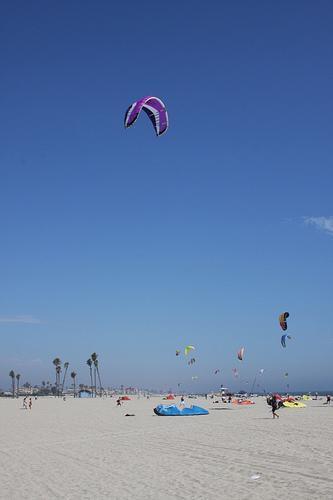How many pieces is the sandwich cut in ot?
Give a very brief answer. 0. 